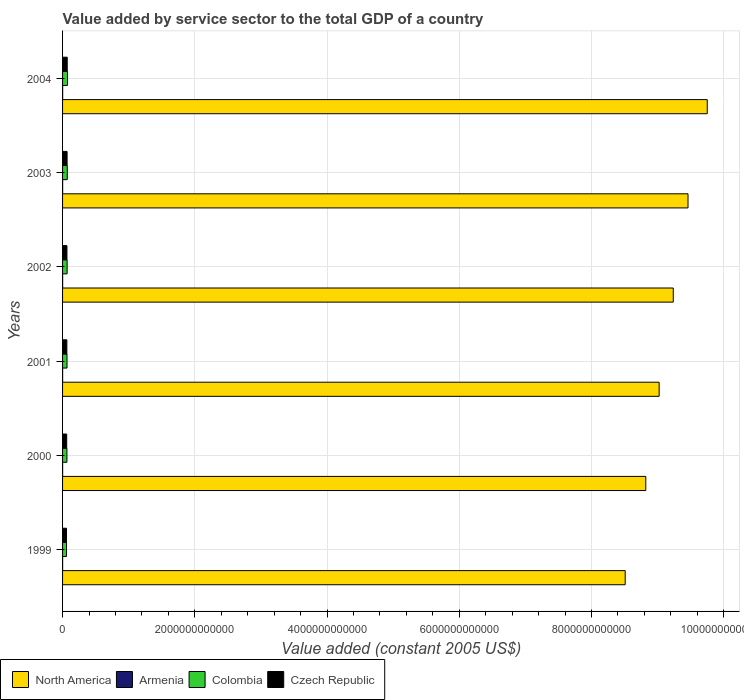In how many cases, is the number of bars for a given year not equal to the number of legend labels?
Keep it short and to the point. 0. What is the value added by service sector in Colombia in 2002?
Your answer should be very brief. 6.89e+1. Across all years, what is the maximum value added by service sector in North America?
Provide a succinct answer. 9.75e+12. Across all years, what is the minimum value added by service sector in North America?
Your response must be concise. 8.51e+12. In which year was the value added by service sector in North America maximum?
Give a very brief answer. 2004. What is the total value added by service sector in Armenia in the graph?
Offer a terse response. 6.06e+09. What is the difference between the value added by service sector in Czech Republic in 2000 and that in 2001?
Keep it short and to the point. -2.32e+09. What is the difference between the value added by service sector in Armenia in 2004 and the value added by service sector in Colombia in 2000?
Keep it short and to the point. -6.45e+1. What is the average value added by service sector in Armenia per year?
Offer a terse response. 1.01e+09. In the year 2004, what is the difference between the value added by service sector in Armenia and value added by service sector in Czech Republic?
Ensure brevity in your answer.  -6.91e+1. What is the ratio of the value added by service sector in North America in 2000 to that in 2001?
Provide a short and direct response. 0.98. Is the difference between the value added by service sector in Armenia in 2001 and 2002 greater than the difference between the value added by service sector in Czech Republic in 2001 and 2002?
Make the answer very short. Yes. What is the difference between the highest and the second highest value added by service sector in North America?
Provide a short and direct response. 2.91e+11. What is the difference between the highest and the lowest value added by service sector in Czech Republic?
Your response must be concise. 1.06e+1. Is it the case that in every year, the sum of the value added by service sector in Czech Republic and value added by service sector in North America is greater than the sum of value added by service sector in Colombia and value added by service sector in Armenia?
Give a very brief answer. Yes. What does the 1st bar from the bottom in 2004 represents?
Make the answer very short. North America. Is it the case that in every year, the sum of the value added by service sector in Colombia and value added by service sector in Armenia is greater than the value added by service sector in North America?
Provide a short and direct response. No. How many bars are there?
Offer a very short reply. 24. Are all the bars in the graph horizontal?
Make the answer very short. Yes. How many years are there in the graph?
Ensure brevity in your answer.  6. What is the difference between two consecutive major ticks on the X-axis?
Provide a short and direct response. 2.00e+12. Are the values on the major ticks of X-axis written in scientific E-notation?
Give a very brief answer. No. Where does the legend appear in the graph?
Your response must be concise. Bottom left. How many legend labels are there?
Offer a terse response. 4. How are the legend labels stacked?
Give a very brief answer. Horizontal. What is the title of the graph?
Keep it short and to the point. Value added by service sector to the total GDP of a country. Does "Bolivia" appear as one of the legend labels in the graph?
Provide a succinct answer. No. What is the label or title of the X-axis?
Provide a short and direct response. Value added (constant 2005 US$). What is the Value added (constant 2005 US$) in North America in 1999?
Ensure brevity in your answer.  8.51e+12. What is the Value added (constant 2005 US$) in Armenia in 1999?
Your response must be concise. 8.71e+08. What is the Value added (constant 2005 US$) in Colombia in 1999?
Your response must be concise. 5.97e+1. What is the Value added (constant 2005 US$) of Czech Republic in 1999?
Your response must be concise. 5.97e+1. What is the Value added (constant 2005 US$) of North America in 2000?
Make the answer very short. 8.82e+12. What is the Value added (constant 2005 US$) of Armenia in 2000?
Keep it short and to the point. 8.15e+08. What is the Value added (constant 2005 US$) in Colombia in 2000?
Offer a terse response. 6.58e+1. What is the Value added (constant 2005 US$) of Czech Republic in 2000?
Your response must be concise. 6.26e+1. What is the Value added (constant 2005 US$) in North America in 2001?
Give a very brief answer. 9.02e+12. What is the Value added (constant 2005 US$) of Armenia in 2001?
Your response must be concise. 8.94e+08. What is the Value added (constant 2005 US$) in Colombia in 2001?
Provide a short and direct response. 6.72e+1. What is the Value added (constant 2005 US$) of Czech Republic in 2001?
Give a very brief answer. 6.49e+1. What is the Value added (constant 2005 US$) in North America in 2002?
Offer a very short reply. 9.24e+12. What is the Value added (constant 2005 US$) of Armenia in 2002?
Make the answer very short. 1.02e+09. What is the Value added (constant 2005 US$) in Colombia in 2002?
Your answer should be compact. 6.89e+1. What is the Value added (constant 2005 US$) in Czech Republic in 2002?
Offer a terse response. 6.60e+1. What is the Value added (constant 2005 US$) of North America in 2003?
Offer a terse response. 9.46e+12. What is the Value added (constant 2005 US$) in Armenia in 2003?
Provide a succinct answer. 1.15e+09. What is the Value added (constant 2005 US$) of Colombia in 2003?
Ensure brevity in your answer.  7.12e+1. What is the Value added (constant 2005 US$) in Czech Republic in 2003?
Give a very brief answer. 6.84e+1. What is the Value added (constant 2005 US$) in North America in 2004?
Give a very brief answer. 9.75e+12. What is the Value added (constant 2005 US$) in Armenia in 2004?
Give a very brief answer. 1.31e+09. What is the Value added (constant 2005 US$) in Colombia in 2004?
Offer a terse response. 7.51e+1. What is the Value added (constant 2005 US$) in Czech Republic in 2004?
Offer a very short reply. 7.04e+1. Across all years, what is the maximum Value added (constant 2005 US$) in North America?
Provide a short and direct response. 9.75e+12. Across all years, what is the maximum Value added (constant 2005 US$) in Armenia?
Make the answer very short. 1.31e+09. Across all years, what is the maximum Value added (constant 2005 US$) of Colombia?
Provide a succinct answer. 7.51e+1. Across all years, what is the maximum Value added (constant 2005 US$) in Czech Republic?
Your answer should be very brief. 7.04e+1. Across all years, what is the minimum Value added (constant 2005 US$) of North America?
Offer a very short reply. 8.51e+12. Across all years, what is the minimum Value added (constant 2005 US$) in Armenia?
Your answer should be compact. 8.15e+08. Across all years, what is the minimum Value added (constant 2005 US$) in Colombia?
Make the answer very short. 5.97e+1. Across all years, what is the minimum Value added (constant 2005 US$) in Czech Republic?
Provide a succinct answer. 5.97e+1. What is the total Value added (constant 2005 US$) of North America in the graph?
Your answer should be very brief. 5.48e+13. What is the total Value added (constant 2005 US$) in Armenia in the graph?
Provide a succinct answer. 6.06e+09. What is the total Value added (constant 2005 US$) in Colombia in the graph?
Your answer should be compact. 4.08e+11. What is the total Value added (constant 2005 US$) of Czech Republic in the graph?
Ensure brevity in your answer.  3.92e+11. What is the difference between the Value added (constant 2005 US$) in North America in 1999 and that in 2000?
Ensure brevity in your answer.  -3.11e+11. What is the difference between the Value added (constant 2005 US$) of Armenia in 1999 and that in 2000?
Your answer should be very brief. 5.53e+07. What is the difference between the Value added (constant 2005 US$) of Colombia in 1999 and that in 2000?
Offer a terse response. -6.11e+09. What is the difference between the Value added (constant 2005 US$) of Czech Republic in 1999 and that in 2000?
Offer a very short reply. -2.88e+09. What is the difference between the Value added (constant 2005 US$) in North America in 1999 and that in 2001?
Make the answer very short. -5.13e+11. What is the difference between the Value added (constant 2005 US$) in Armenia in 1999 and that in 2001?
Offer a terse response. -2.38e+07. What is the difference between the Value added (constant 2005 US$) of Colombia in 1999 and that in 2001?
Make the answer very short. -7.53e+09. What is the difference between the Value added (constant 2005 US$) of Czech Republic in 1999 and that in 2001?
Provide a short and direct response. -5.19e+09. What is the difference between the Value added (constant 2005 US$) in North America in 1999 and that in 2002?
Ensure brevity in your answer.  -7.27e+11. What is the difference between the Value added (constant 2005 US$) in Armenia in 1999 and that in 2002?
Your response must be concise. -1.48e+08. What is the difference between the Value added (constant 2005 US$) of Colombia in 1999 and that in 2002?
Give a very brief answer. -9.19e+09. What is the difference between the Value added (constant 2005 US$) of Czech Republic in 1999 and that in 2002?
Offer a very short reply. -6.28e+09. What is the difference between the Value added (constant 2005 US$) of North America in 1999 and that in 2003?
Give a very brief answer. -9.50e+11. What is the difference between the Value added (constant 2005 US$) of Armenia in 1999 and that in 2003?
Keep it short and to the point. -2.79e+08. What is the difference between the Value added (constant 2005 US$) in Colombia in 1999 and that in 2003?
Ensure brevity in your answer.  -1.15e+1. What is the difference between the Value added (constant 2005 US$) in Czech Republic in 1999 and that in 2003?
Your answer should be compact. -8.66e+09. What is the difference between the Value added (constant 2005 US$) in North America in 1999 and that in 2004?
Offer a terse response. -1.24e+12. What is the difference between the Value added (constant 2005 US$) of Armenia in 1999 and that in 2004?
Make the answer very short. -4.38e+08. What is the difference between the Value added (constant 2005 US$) in Colombia in 1999 and that in 2004?
Keep it short and to the point. -1.54e+1. What is the difference between the Value added (constant 2005 US$) in Czech Republic in 1999 and that in 2004?
Offer a terse response. -1.06e+1. What is the difference between the Value added (constant 2005 US$) of North America in 2000 and that in 2001?
Make the answer very short. -2.02e+11. What is the difference between the Value added (constant 2005 US$) in Armenia in 2000 and that in 2001?
Your answer should be very brief. -7.90e+07. What is the difference between the Value added (constant 2005 US$) in Colombia in 2000 and that in 2001?
Give a very brief answer. -1.42e+09. What is the difference between the Value added (constant 2005 US$) of Czech Republic in 2000 and that in 2001?
Your response must be concise. -2.32e+09. What is the difference between the Value added (constant 2005 US$) in North America in 2000 and that in 2002?
Keep it short and to the point. -4.16e+11. What is the difference between the Value added (constant 2005 US$) of Armenia in 2000 and that in 2002?
Offer a terse response. -2.03e+08. What is the difference between the Value added (constant 2005 US$) of Colombia in 2000 and that in 2002?
Your response must be concise. -3.07e+09. What is the difference between the Value added (constant 2005 US$) in Czech Republic in 2000 and that in 2002?
Your response must be concise. -3.40e+09. What is the difference between the Value added (constant 2005 US$) of North America in 2000 and that in 2003?
Your response must be concise. -6.39e+11. What is the difference between the Value added (constant 2005 US$) of Armenia in 2000 and that in 2003?
Provide a succinct answer. -3.34e+08. What is the difference between the Value added (constant 2005 US$) in Colombia in 2000 and that in 2003?
Ensure brevity in your answer.  -5.41e+09. What is the difference between the Value added (constant 2005 US$) in Czech Republic in 2000 and that in 2003?
Your response must be concise. -5.79e+09. What is the difference between the Value added (constant 2005 US$) of North America in 2000 and that in 2004?
Give a very brief answer. -9.30e+11. What is the difference between the Value added (constant 2005 US$) of Armenia in 2000 and that in 2004?
Make the answer very short. -4.93e+08. What is the difference between the Value added (constant 2005 US$) in Colombia in 2000 and that in 2004?
Offer a terse response. -9.33e+09. What is the difference between the Value added (constant 2005 US$) in Czech Republic in 2000 and that in 2004?
Ensure brevity in your answer.  -7.77e+09. What is the difference between the Value added (constant 2005 US$) in North America in 2001 and that in 2002?
Make the answer very short. -2.14e+11. What is the difference between the Value added (constant 2005 US$) in Armenia in 2001 and that in 2002?
Your answer should be very brief. -1.24e+08. What is the difference between the Value added (constant 2005 US$) in Colombia in 2001 and that in 2002?
Your answer should be very brief. -1.65e+09. What is the difference between the Value added (constant 2005 US$) of Czech Republic in 2001 and that in 2002?
Your response must be concise. -1.08e+09. What is the difference between the Value added (constant 2005 US$) of North America in 2001 and that in 2003?
Give a very brief answer. -4.37e+11. What is the difference between the Value added (constant 2005 US$) in Armenia in 2001 and that in 2003?
Make the answer very short. -2.55e+08. What is the difference between the Value added (constant 2005 US$) of Colombia in 2001 and that in 2003?
Keep it short and to the point. -3.99e+09. What is the difference between the Value added (constant 2005 US$) of Czech Republic in 2001 and that in 2003?
Make the answer very short. -3.47e+09. What is the difference between the Value added (constant 2005 US$) of North America in 2001 and that in 2004?
Offer a very short reply. -7.28e+11. What is the difference between the Value added (constant 2005 US$) of Armenia in 2001 and that in 2004?
Make the answer very short. -4.14e+08. What is the difference between the Value added (constant 2005 US$) in Colombia in 2001 and that in 2004?
Provide a succinct answer. -7.91e+09. What is the difference between the Value added (constant 2005 US$) of Czech Republic in 2001 and that in 2004?
Your response must be concise. -5.45e+09. What is the difference between the Value added (constant 2005 US$) of North America in 2002 and that in 2003?
Provide a succinct answer. -2.23e+11. What is the difference between the Value added (constant 2005 US$) of Armenia in 2002 and that in 2003?
Your response must be concise. -1.31e+08. What is the difference between the Value added (constant 2005 US$) in Colombia in 2002 and that in 2003?
Provide a short and direct response. -2.34e+09. What is the difference between the Value added (constant 2005 US$) of Czech Republic in 2002 and that in 2003?
Your answer should be very brief. -2.39e+09. What is the difference between the Value added (constant 2005 US$) of North America in 2002 and that in 2004?
Ensure brevity in your answer.  -5.14e+11. What is the difference between the Value added (constant 2005 US$) of Armenia in 2002 and that in 2004?
Offer a very short reply. -2.90e+08. What is the difference between the Value added (constant 2005 US$) of Colombia in 2002 and that in 2004?
Give a very brief answer. -6.26e+09. What is the difference between the Value added (constant 2005 US$) in Czech Republic in 2002 and that in 2004?
Your answer should be compact. -4.37e+09. What is the difference between the Value added (constant 2005 US$) in North America in 2003 and that in 2004?
Give a very brief answer. -2.91e+11. What is the difference between the Value added (constant 2005 US$) in Armenia in 2003 and that in 2004?
Give a very brief answer. -1.59e+08. What is the difference between the Value added (constant 2005 US$) in Colombia in 2003 and that in 2004?
Your answer should be very brief. -3.92e+09. What is the difference between the Value added (constant 2005 US$) in Czech Republic in 2003 and that in 2004?
Offer a terse response. -1.98e+09. What is the difference between the Value added (constant 2005 US$) in North America in 1999 and the Value added (constant 2005 US$) in Armenia in 2000?
Give a very brief answer. 8.51e+12. What is the difference between the Value added (constant 2005 US$) of North America in 1999 and the Value added (constant 2005 US$) of Colombia in 2000?
Ensure brevity in your answer.  8.44e+12. What is the difference between the Value added (constant 2005 US$) in North America in 1999 and the Value added (constant 2005 US$) in Czech Republic in 2000?
Give a very brief answer. 8.45e+12. What is the difference between the Value added (constant 2005 US$) in Armenia in 1999 and the Value added (constant 2005 US$) in Colombia in 2000?
Provide a short and direct response. -6.49e+1. What is the difference between the Value added (constant 2005 US$) of Armenia in 1999 and the Value added (constant 2005 US$) of Czech Republic in 2000?
Make the answer very short. -6.17e+1. What is the difference between the Value added (constant 2005 US$) of Colombia in 1999 and the Value added (constant 2005 US$) of Czech Republic in 2000?
Your answer should be very brief. -2.93e+09. What is the difference between the Value added (constant 2005 US$) in North America in 1999 and the Value added (constant 2005 US$) in Armenia in 2001?
Make the answer very short. 8.51e+12. What is the difference between the Value added (constant 2005 US$) of North America in 1999 and the Value added (constant 2005 US$) of Colombia in 2001?
Give a very brief answer. 8.44e+12. What is the difference between the Value added (constant 2005 US$) in North America in 1999 and the Value added (constant 2005 US$) in Czech Republic in 2001?
Your answer should be compact. 8.45e+12. What is the difference between the Value added (constant 2005 US$) in Armenia in 1999 and the Value added (constant 2005 US$) in Colombia in 2001?
Provide a short and direct response. -6.63e+1. What is the difference between the Value added (constant 2005 US$) in Armenia in 1999 and the Value added (constant 2005 US$) in Czech Republic in 2001?
Provide a short and direct response. -6.41e+1. What is the difference between the Value added (constant 2005 US$) of Colombia in 1999 and the Value added (constant 2005 US$) of Czech Republic in 2001?
Your response must be concise. -5.25e+09. What is the difference between the Value added (constant 2005 US$) in North America in 1999 and the Value added (constant 2005 US$) in Armenia in 2002?
Provide a short and direct response. 8.51e+12. What is the difference between the Value added (constant 2005 US$) in North America in 1999 and the Value added (constant 2005 US$) in Colombia in 2002?
Ensure brevity in your answer.  8.44e+12. What is the difference between the Value added (constant 2005 US$) in North America in 1999 and the Value added (constant 2005 US$) in Czech Republic in 2002?
Your response must be concise. 8.44e+12. What is the difference between the Value added (constant 2005 US$) in Armenia in 1999 and the Value added (constant 2005 US$) in Colombia in 2002?
Your answer should be very brief. -6.80e+1. What is the difference between the Value added (constant 2005 US$) in Armenia in 1999 and the Value added (constant 2005 US$) in Czech Republic in 2002?
Provide a short and direct response. -6.51e+1. What is the difference between the Value added (constant 2005 US$) in Colombia in 1999 and the Value added (constant 2005 US$) in Czech Republic in 2002?
Your response must be concise. -6.33e+09. What is the difference between the Value added (constant 2005 US$) in North America in 1999 and the Value added (constant 2005 US$) in Armenia in 2003?
Your answer should be very brief. 8.51e+12. What is the difference between the Value added (constant 2005 US$) in North America in 1999 and the Value added (constant 2005 US$) in Colombia in 2003?
Your response must be concise. 8.44e+12. What is the difference between the Value added (constant 2005 US$) in North America in 1999 and the Value added (constant 2005 US$) in Czech Republic in 2003?
Ensure brevity in your answer.  8.44e+12. What is the difference between the Value added (constant 2005 US$) of Armenia in 1999 and the Value added (constant 2005 US$) of Colombia in 2003?
Make the answer very short. -7.03e+1. What is the difference between the Value added (constant 2005 US$) of Armenia in 1999 and the Value added (constant 2005 US$) of Czech Republic in 2003?
Your answer should be very brief. -6.75e+1. What is the difference between the Value added (constant 2005 US$) of Colombia in 1999 and the Value added (constant 2005 US$) of Czech Republic in 2003?
Give a very brief answer. -8.72e+09. What is the difference between the Value added (constant 2005 US$) of North America in 1999 and the Value added (constant 2005 US$) of Armenia in 2004?
Provide a short and direct response. 8.51e+12. What is the difference between the Value added (constant 2005 US$) in North America in 1999 and the Value added (constant 2005 US$) in Colombia in 2004?
Your response must be concise. 8.44e+12. What is the difference between the Value added (constant 2005 US$) in North America in 1999 and the Value added (constant 2005 US$) in Czech Republic in 2004?
Your answer should be very brief. 8.44e+12. What is the difference between the Value added (constant 2005 US$) of Armenia in 1999 and the Value added (constant 2005 US$) of Colombia in 2004?
Your answer should be very brief. -7.43e+1. What is the difference between the Value added (constant 2005 US$) of Armenia in 1999 and the Value added (constant 2005 US$) of Czech Republic in 2004?
Provide a succinct answer. -6.95e+1. What is the difference between the Value added (constant 2005 US$) in Colombia in 1999 and the Value added (constant 2005 US$) in Czech Republic in 2004?
Provide a short and direct response. -1.07e+1. What is the difference between the Value added (constant 2005 US$) in North America in 2000 and the Value added (constant 2005 US$) in Armenia in 2001?
Offer a very short reply. 8.82e+12. What is the difference between the Value added (constant 2005 US$) in North America in 2000 and the Value added (constant 2005 US$) in Colombia in 2001?
Make the answer very short. 8.75e+12. What is the difference between the Value added (constant 2005 US$) in North America in 2000 and the Value added (constant 2005 US$) in Czech Republic in 2001?
Provide a succinct answer. 8.76e+12. What is the difference between the Value added (constant 2005 US$) in Armenia in 2000 and the Value added (constant 2005 US$) in Colombia in 2001?
Give a very brief answer. -6.64e+1. What is the difference between the Value added (constant 2005 US$) of Armenia in 2000 and the Value added (constant 2005 US$) of Czech Republic in 2001?
Your answer should be compact. -6.41e+1. What is the difference between the Value added (constant 2005 US$) in Colombia in 2000 and the Value added (constant 2005 US$) in Czech Republic in 2001?
Give a very brief answer. 8.67e+08. What is the difference between the Value added (constant 2005 US$) of North America in 2000 and the Value added (constant 2005 US$) of Armenia in 2002?
Offer a terse response. 8.82e+12. What is the difference between the Value added (constant 2005 US$) in North America in 2000 and the Value added (constant 2005 US$) in Colombia in 2002?
Give a very brief answer. 8.75e+12. What is the difference between the Value added (constant 2005 US$) of North America in 2000 and the Value added (constant 2005 US$) of Czech Republic in 2002?
Your answer should be very brief. 8.76e+12. What is the difference between the Value added (constant 2005 US$) of Armenia in 2000 and the Value added (constant 2005 US$) of Colombia in 2002?
Provide a succinct answer. -6.81e+1. What is the difference between the Value added (constant 2005 US$) in Armenia in 2000 and the Value added (constant 2005 US$) in Czech Republic in 2002?
Provide a short and direct response. -6.52e+1. What is the difference between the Value added (constant 2005 US$) of Colombia in 2000 and the Value added (constant 2005 US$) of Czech Republic in 2002?
Give a very brief answer. -2.14e+08. What is the difference between the Value added (constant 2005 US$) in North America in 2000 and the Value added (constant 2005 US$) in Armenia in 2003?
Your answer should be compact. 8.82e+12. What is the difference between the Value added (constant 2005 US$) in North America in 2000 and the Value added (constant 2005 US$) in Colombia in 2003?
Give a very brief answer. 8.75e+12. What is the difference between the Value added (constant 2005 US$) in North America in 2000 and the Value added (constant 2005 US$) in Czech Republic in 2003?
Your answer should be very brief. 8.75e+12. What is the difference between the Value added (constant 2005 US$) of Armenia in 2000 and the Value added (constant 2005 US$) of Colombia in 2003?
Ensure brevity in your answer.  -7.04e+1. What is the difference between the Value added (constant 2005 US$) of Armenia in 2000 and the Value added (constant 2005 US$) of Czech Republic in 2003?
Offer a very short reply. -6.76e+1. What is the difference between the Value added (constant 2005 US$) of Colombia in 2000 and the Value added (constant 2005 US$) of Czech Republic in 2003?
Offer a very short reply. -2.60e+09. What is the difference between the Value added (constant 2005 US$) in North America in 2000 and the Value added (constant 2005 US$) in Armenia in 2004?
Offer a terse response. 8.82e+12. What is the difference between the Value added (constant 2005 US$) in North America in 2000 and the Value added (constant 2005 US$) in Colombia in 2004?
Provide a succinct answer. 8.75e+12. What is the difference between the Value added (constant 2005 US$) of North America in 2000 and the Value added (constant 2005 US$) of Czech Republic in 2004?
Ensure brevity in your answer.  8.75e+12. What is the difference between the Value added (constant 2005 US$) in Armenia in 2000 and the Value added (constant 2005 US$) in Colombia in 2004?
Ensure brevity in your answer.  -7.43e+1. What is the difference between the Value added (constant 2005 US$) in Armenia in 2000 and the Value added (constant 2005 US$) in Czech Republic in 2004?
Provide a short and direct response. -6.96e+1. What is the difference between the Value added (constant 2005 US$) in Colombia in 2000 and the Value added (constant 2005 US$) in Czech Republic in 2004?
Make the answer very short. -4.58e+09. What is the difference between the Value added (constant 2005 US$) in North America in 2001 and the Value added (constant 2005 US$) in Armenia in 2002?
Provide a short and direct response. 9.02e+12. What is the difference between the Value added (constant 2005 US$) in North America in 2001 and the Value added (constant 2005 US$) in Colombia in 2002?
Your response must be concise. 8.95e+12. What is the difference between the Value added (constant 2005 US$) of North America in 2001 and the Value added (constant 2005 US$) of Czech Republic in 2002?
Make the answer very short. 8.96e+12. What is the difference between the Value added (constant 2005 US$) of Armenia in 2001 and the Value added (constant 2005 US$) of Colombia in 2002?
Your answer should be compact. -6.80e+1. What is the difference between the Value added (constant 2005 US$) in Armenia in 2001 and the Value added (constant 2005 US$) in Czech Republic in 2002?
Your answer should be compact. -6.51e+1. What is the difference between the Value added (constant 2005 US$) of Colombia in 2001 and the Value added (constant 2005 US$) of Czech Republic in 2002?
Offer a very short reply. 1.20e+09. What is the difference between the Value added (constant 2005 US$) of North America in 2001 and the Value added (constant 2005 US$) of Armenia in 2003?
Your response must be concise. 9.02e+12. What is the difference between the Value added (constant 2005 US$) in North America in 2001 and the Value added (constant 2005 US$) in Colombia in 2003?
Your answer should be compact. 8.95e+12. What is the difference between the Value added (constant 2005 US$) in North America in 2001 and the Value added (constant 2005 US$) in Czech Republic in 2003?
Give a very brief answer. 8.96e+12. What is the difference between the Value added (constant 2005 US$) of Armenia in 2001 and the Value added (constant 2005 US$) of Colombia in 2003?
Your answer should be compact. -7.03e+1. What is the difference between the Value added (constant 2005 US$) in Armenia in 2001 and the Value added (constant 2005 US$) in Czech Republic in 2003?
Your response must be concise. -6.75e+1. What is the difference between the Value added (constant 2005 US$) in Colombia in 2001 and the Value added (constant 2005 US$) in Czech Republic in 2003?
Ensure brevity in your answer.  -1.18e+09. What is the difference between the Value added (constant 2005 US$) in North America in 2001 and the Value added (constant 2005 US$) in Armenia in 2004?
Provide a short and direct response. 9.02e+12. What is the difference between the Value added (constant 2005 US$) in North America in 2001 and the Value added (constant 2005 US$) in Colombia in 2004?
Your answer should be very brief. 8.95e+12. What is the difference between the Value added (constant 2005 US$) in North America in 2001 and the Value added (constant 2005 US$) in Czech Republic in 2004?
Your response must be concise. 8.95e+12. What is the difference between the Value added (constant 2005 US$) in Armenia in 2001 and the Value added (constant 2005 US$) in Colombia in 2004?
Your answer should be compact. -7.42e+1. What is the difference between the Value added (constant 2005 US$) of Armenia in 2001 and the Value added (constant 2005 US$) of Czech Republic in 2004?
Provide a succinct answer. -6.95e+1. What is the difference between the Value added (constant 2005 US$) in Colombia in 2001 and the Value added (constant 2005 US$) in Czech Republic in 2004?
Your answer should be very brief. -3.16e+09. What is the difference between the Value added (constant 2005 US$) of North America in 2002 and the Value added (constant 2005 US$) of Armenia in 2003?
Offer a terse response. 9.24e+12. What is the difference between the Value added (constant 2005 US$) in North America in 2002 and the Value added (constant 2005 US$) in Colombia in 2003?
Keep it short and to the point. 9.17e+12. What is the difference between the Value added (constant 2005 US$) in North America in 2002 and the Value added (constant 2005 US$) in Czech Republic in 2003?
Offer a very short reply. 9.17e+12. What is the difference between the Value added (constant 2005 US$) in Armenia in 2002 and the Value added (constant 2005 US$) in Colombia in 2003?
Ensure brevity in your answer.  -7.02e+1. What is the difference between the Value added (constant 2005 US$) in Armenia in 2002 and the Value added (constant 2005 US$) in Czech Republic in 2003?
Keep it short and to the point. -6.74e+1. What is the difference between the Value added (constant 2005 US$) in Colombia in 2002 and the Value added (constant 2005 US$) in Czech Republic in 2003?
Offer a very short reply. 4.68e+08. What is the difference between the Value added (constant 2005 US$) in North America in 2002 and the Value added (constant 2005 US$) in Armenia in 2004?
Keep it short and to the point. 9.24e+12. What is the difference between the Value added (constant 2005 US$) of North America in 2002 and the Value added (constant 2005 US$) of Colombia in 2004?
Ensure brevity in your answer.  9.16e+12. What is the difference between the Value added (constant 2005 US$) in North America in 2002 and the Value added (constant 2005 US$) in Czech Republic in 2004?
Provide a short and direct response. 9.17e+12. What is the difference between the Value added (constant 2005 US$) of Armenia in 2002 and the Value added (constant 2005 US$) of Colombia in 2004?
Ensure brevity in your answer.  -7.41e+1. What is the difference between the Value added (constant 2005 US$) of Armenia in 2002 and the Value added (constant 2005 US$) of Czech Republic in 2004?
Give a very brief answer. -6.94e+1. What is the difference between the Value added (constant 2005 US$) of Colombia in 2002 and the Value added (constant 2005 US$) of Czech Republic in 2004?
Keep it short and to the point. -1.51e+09. What is the difference between the Value added (constant 2005 US$) in North America in 2003 and the Value added (constant 2005 US$) in Armenia in 2004?
Your response must be concise. 9.46e+12. What is the difference between the Value added (constant 2005 US$) in North America in 2003 and the Value added (constant 2005 US$) in Colombia in 2004?
Offer a terse response. 9.39e+12. What is the difference between the Value added (constant 2005 US$) of North America in 2003 and the Value added (constant 2005 US$) of Czech Republic in 2004?
Make the answer very short. 9.39e+12. What is the difference between the Value added (constant 2005 US$) in Armenia in 2003 and the Value added (constant 2005 US$) in Colombia in 2004?
Give a very brief answer. -7.40e+1. What is the difference between the Value added (constant 2005 US$) of Armenia in 2003 and the Value added (constant 2005 US$) of Czech Republic in 2004?
Your answer should be very brief. -6.92e+1. What is the difference between the Value added (constant 2005 US$) of Colombia in 2003 and the Value added (constant 2005 US$) of Czech Republic in 2004?
Make the answer very short. 8.26e+08. What is the average Value added (constant 2005 US$) in North America per year?
Ensure brevity in your answer.  9.13e+12. What is the average Value added (constant 2005 US$) in Armenia per year?
Provide a succinct answer. 1.01e+09. What is the average Value added (constant 2005 US$) of Colombia per year?
Keep it short and to the point. 6.80e+1. What is the average Value added (constant 2005 US$) of Czech Republic per year?
Your response must be concise. 6.53e+1. In the year 1999, what is the difference between the Value added (constant 2005 US$) of North America and Value added (constant 2005 US$) of Armenia?
Your response must be concise. 8.51e+12. In the year 1999, what is the difference between the Value added (constant 2005 US$) of North America and Value added (constant 2005 US$) of Colombia?
Make the answer very short. 8.45e+12. In the year 1999, what is the difference between the Value added (constant 2005 US$) of North America and Value added (constant 2005 US$) of Czech Republic?
Offer a terse response. 8.45e+12. In the year 1999, what is the difference between the Value added (constant 2005 US$) of Armenia and Value added (constant 2005 US$) of Colombia?
Provide a short and direct response. -5.88e+1. In the year 1999, what is the difference between the Value added (constant 2005 US$) in Armenia and Value added (constant 2005 US$) in Czech Republic?
Your answer should be very brief. -5.89e+1. In the year 1999, what is the difference between the Value added (constant 2005 US$) in Colombia and Value added (constant 2005 US$) in Czech Republic?
Make the answer very short. -5.26e+07. In the year 2000, what is the difference between the Value added (constant 2005 US$) of North America and Value added (constant 2005 US$) of Armenia?
Offer a terse response. 8.82e+12. In the year 2000, what is the difference between the Value added (constant 2005 US$) of North America and Value added (constant 2005 US$) of Colombia?
Give a very brief answer. 8.76e+12. In the year 2000, what is the difference between the Value added (constant 2005 US$) of North America and Value added (constant 2005 US$) of Czech Republic?
Offer a very short reply. 8.76e+12. In the year 2000, what is the difference between the Value added (constant 2005 US$) of Armenia and Value added (constant 2005 US$) of Colombia?
Offer a very short reply. -6.50e+1. In the year 2000, what is the difference between the Value added (constant 2005 US$) of Armenia and Value added (constant 2005 US$) of Czech Republic?
Provide a short and direct response. -6.18e+1. In the year 2000, what is the difference between the Value added (constant 2005 US$) in Colombia and Value added (constant 2005 US$) in Czech Republic?
Your answer should be compact. 3.18e+09. In the year 2001, what is the difference between the Value added (constant 2005 US$) in North America and Value added (constant 2005 US$) in Armenia?
Your response must be concise. 9.02e+12. In the year 2001, what is the difference between the Value added (constant 2005 US$) of North America and Value added (constant 2005 US$) of Colombia?
Make the answer very short. 8.96e+12. In the year 2001, what is the difference between the Value added (constant 2005 US$) in North America and Value added (constant 2005 US$) in Czech Republic?
Provide a succinct answer. 8.96e+12. In the year 2001, what is the difference between the Value added (constant 2005 US$) in Armenia and Value added (constant 2005 US$) in Colombia?
Make the answer very short. -6.63e+1. In the year 2001, what is the difference between the Value added (constant 2005 US$) in Armenia and Value added (constant 2005 US$) in Czech Republic?
Your answer should be very brief. -6.40e+1. In the year 2001, what is the difference between the Value added (constant 2005 US$) of Colombia and Value added (constant 2005 US$) of Czech Republic?
Give a very brief answer. 2.29e+09. In the year 2002, what is the difference between the Value added (constant 2005 US$) of North America and Value added (constant 2005 US$) of Armenia?
Your answer should be compact. 9.24e+12. In the year 2002, what is the difference between the Value added (constant 2005 US$) in North America and Value added (constant 2005 US$) in Colombia?
Offer a terse response. 9.17e+12. In the year 2002, what is the difference between the Value added (constant 2005 US$) of North America and Value added (constant 2005 US$) of Czech Republic?
Your answer should be very brief. 9.17e+12. In the year 2002, what is the difference between the Value added (constant 2005 US$) of Armenia and Value added (constant 2005 US$) of Colombia?
Make the answer very short. -6.79e+1. In the year 2002, what is the difference between the Value added (constant 2005 US$) of Armenia and Value added (constant 2005 US$) of Czech Republic?
Ensure brevity in your answer.  -6.50e+1. In the year 2002, what is the difference between the Value added (constant 2005 US$) of Colombia and Value added (constant 2005 US$) of Czech Republic?
Make the answer very short. 2.86e+09. In the year 2003, what is the difference between the Value added (constant 2005 US$) in North America and Value added (constant 2005 US$) in Armenia?
Your answer should be very brief. 9.46e+12. In the year 2003, what is the difference between the Value added (constant 2005 US$) in North America and Value added (constant 2005 US$) in Colombia?
Make the answer very short. 9.39e+12. In the year 2003, what is the difference between the Value added (constant 2005 US$) in North America and Value added (constant 2005 US$) in Czech Republic?
Ensure brevity in your answer.  9.39e+12. In the year 2003, what is the difference between the Value added (constant 2005 US$) of Armenia and Value added (constant 2005 US$) of Colombia?
Keep it short and to the point. -7.01e+1. In the year 2003, what is the difference between the Value added (constant 2005 US$) in Armenia and Value added (constant 2005 US$) in Czech Republic?
Provide a succinct answer. -6.73e+1. In the year 2003, what is the difference between the Value added (constant 2005 US$) in Colombia and Value added (constant 2005 US$) in Czech Republic?
Offer a terse response. 2.80e+09. In the year 2004, what is the difference between the Value added (constant 2005 US$) of North America and Value added (constant 2005 US$) of Armenia?
Make the answer very short. 9.75e+12. In the year 2004, what is the difference between the Value added (constant 2005 US$) of North America and Value added (constant 2005 US$) of Colombia?
Your answer should be very brief. 9.68e+12. In the year 2004, what is the difference between the Value added (constant 2005 US$) of North America and Value added (constant 2005 US$) of Czech Republic?
Provide a succinct answer. 9.68e+12. In the year 2004, what is the difference between the Value added (constant 2005 US$) of Armenia and Value added (constant 2005 US$) of Colombia?
Make the answer very short. -7.38e+1. In the year 2004, what is the difference between the Value added (constant 2005 US$) of Armenia and Value added (constant 2005 US$) of Czech Republic?
Make the answer very short. -6.91e+1. In the year 2004, what is the difference between the Value added (constant 2005 US$) in Colombia and Value added (constant 2005 US$) in Czech Republic?
Offer a terse response. 4.75e+09. What is the ratio of the Value added (constant 2005 US$) of North America in 1999 to that in 2000?
Provide a short and direct response. 0.96. What is the ratio of the Value added (constant 2005 US$) of Armenia in 1999 to that in 2000?
Offer a very short reply. 1.07. What is the ratio of the Value added (constant 2005 US$) of Colombia in 1999 to that in 2000?
Keep it short and to the point. 0.91. What is the ratio of the Value added (constant 2005 US$) in Czech Republic in 1999 to that in 2000?
Your answer should be very brief. 0.95. What is the ratio of the Value added (constant 2005 US$) of North America in 1999 to that in 2001?
Your answer should be very brief. 0.94. What is the ratio of the Value added (constant 2005 US$) in Armenia in 1999 to that in 2001?
Make the answer very short. 0.97. What is the ratio of the Value added (constant 2005 US$) of Colombia in 1999 to that in 2001?
Your response must be concise. 0.89. What is the ratio of the Value added (constant 2005 US$) of North America in 1999 to that in 2002?
Make the answer very short. 0.92. What is the ratio of the Value added (constant 2005 US$) of Armenia in 1999 to that in 2002?
Give a very brief answer. 0.86. What is the ratio of the Value added (constant 2005 US$) of Colombia in 1999 to that in 2002?
Your response must be concise. 0.87. What is the ratio of the Value added (constant 2005 US$) in Czech Republic in 1999 to that in 2002?
Provide a succinct answer. 0.9. What is the ratio of the Value added (constant 2005 US$) in North America in 1999 to that in 2003?
Ensure brevity in your answer.  0.9. What is the ratio of the Value added (constant 2005 US$) of Armenia in 1999 to that in 2003?
Your answer should be very brief. 0.76. What is the ratio of the Value added (constant 2005 US$) in Colombia in 1999 to that in 2003?
Your answer should be compact. 0.84. What is the ratio of the Value added (constant 2005 US$) in Czech Republic in 1999 to that in 2003?
Offer a terse response. 0.87. What is the ratio of the Value added (constant 2005 US$) in North America in 1999 to that in 2004?
Ensure brevity in your answer.  0.87. What is the ratio of the Value added (constant 2005 US$) of Armenia in 1999 to that in 2004?
Your answer should be compact. 0.67. What is the ratio of the Value added (constant 2005 US$) in Colombia in 1999 to that in 2004?
Ensure brevity in your answer.  0.79. What is the ratio of the Value added (constant 2005 US$) in Czech Republic in 1999 to that in 2004?
Give a very brief answer. 0.85. What is the ratio of the Value added (constant 2005 US$) of North America in 2000 to that in 2001?
Your response must be concise. 0.98. What is the ratio of the Value added (constant 2005 US$) in Armenia in 2000 to that in 2001?
Offer a very short reply. 0.91. What is the ratio of the Value added (constant 2005 US$) in Colombia in 2000 to that in 2001?
Provide a short and direct response. 0.98. What is the ratio of the Value added (constant 2005 US$) in North America in 2000 to that in 2002?
Your answer should be very brief. 0.95. What is the ratio of the Value added (constant 2005 US$) of Armenia in 2000 to that in 2002?
Keep it short and to the point. 0.8. What is the ratio of the Value added (constant 2005 US$) of Colombia in 2000 to that in 2002?
Keep it short and to the point. 0.96. What is the ratio of the Value added (constant 2005 US$) of Czech Republic in 2000 to that in 2002?
Provide a succinct answer. 0.95. What is the ratio of the Value added (constant 2005 US$) in North America in 2000 to that in 2003?
Your answer should be compact. 0.93. What is the ratio of the Value added (constant 2005 US$) in Armenia in 2000 to that in 2003?
Offer a very short reply. 0.71. What is the ratio of the Value added (constant 2005 US$) of Colombia in 2000 to that in 2003?
Ensure brevity in your answer.  0.92. What is the ratio of the Value added (constant 2005 US$) in Czech Republic in 2000 to that in 2003?
Provide a short and direct response. 0.92. What is the ratio of the Value added (constant 2005 US$) of North America in 2000 to that in 2004?
Give a very brief answer. 0.9. What is the ratio of the Value added (constant 2005 US$) in Armenia in 2000 to that in 2004?
Your answer should be compact. 0.62. What is the ratio of the Value added (constant 2005 US$) of Colombia in 2000 to that in 2004?
Your response must be concise. 0.88. What is the ratio of the Value added (constant 2005 US$) of Czech Republic in 2000 to that in 2004?
Offer a terse response. 0.89. What is the ratio of the Value added (constant 2005 US$) in North America in 2001 to that in 2002?
Provide a succinct answer. 0.98. What is the ratio of the Value added (constant 2005 US$) of Armenia in 2001 to that in 2002?
Offer a terse response. 0.88. What is the ratio of the Value added (constant 2005 US$) of Colombia in 2001 to that in 2002?
Your response must be concise. 0.98. What is the ratio of the Value added (constant 2005 US$) of Czech Republic in 2001 to that in 2002?
Make the answer very short. 0.98. What is the ratio of the Value added (constant 2005 US$) in North America in 2001 to that in 2003?
Provide a succinct answer. 0.95. What is the ratio of the Value added (constant 2005 US$) of Armenia in 2001 to that in 2003?
Keep it short and to the point. 0.78. What is the ratio of the Value added (constant 2005 US$) of Colombia in 2001 to that in 2003?
Your answer should be very brief. 0.94. What is the ratio of the Value added (constant 2005 US$) of Czech Republic in 2001 to that in 2003?
Give a very brief answer. 0.95. What is the ratio of the Value added (constant 2005 US$) in North America in 2001 to that in 2004?
Keep it short and to the point. 0.93. What is the ratio of the Value added (constant 2005 US$) in Armenia in 2001 to that in 2004?
Provide a succinct answer. 0.68. What is the ratio of the Value added (constant 2005 US$) in Colombia in 2001 to that in 2004?
Your answer should be compact. 0.89. What is the ratio of the Value added (constant 2005 US$) of Czech Republic in 2001 to that in 2004?
Keep it short and to the point. 0.92. What is the ratio of the Value added (constant 2005 US$) of North America in 2002 to that in 2003?
Ensure brevity in your answer.  0.98. What is the ratio of the Value added (constant 2005 US$) in Armenia in 2002 to that in 2003?
Ensure brevity in your answer.  0.89. What is the ratio of the Value added (constant 2005 US$) of Colombia in 2002 to that in 2003?
Give a very brief answer. 0.97. What is the ratio of the Value added (constant 2005 US$) in Czech Republic in 2002 to that in 2003?
Provide a short and direct response. 0.97. What is the ratio of the Value added (constant 2005 US$) in North America in 2002 to that in 2004?
Provide a succinct answer. 0.95. What is the ratio of the Value added (constant 2005 US$) in Armenia in 2002 to that in 2004?
Your answer should be very brief. 0.78. What is the ratio of the Value added (constant 2005 US$) in Colombia in 2002 to that in 2004?
Give a very brief answer. 0.92. What is the ratio of the Value added (constant 2005 US$) of Czech Republic in 2002 to that in 2004?
Offer a terse response. 0.94. What is the ratio of the Value added (constant 2005 US$) of North America in 2003 to that in 2004?
Give a very brief answer. 0.97. What is the ratio of the Value added (constant 2005 US$) in Armenia in 2003 to that in 2004?
Ensure brevity in your answer.  0.88. What is the ratio of the Value added (constant 2005 US$) of Colombia in 2003 to that in 2004?
Keep it short and to the point. 0.95. What is the ratio of the Value added (constant 2005 US$) in Czech Republic in 2003 to that in 2004?
Your answer should be very brief. 0.97. What is the difference between the highest and the second highest Value added (constant 2005 US$) in North America?
Provide a succinct answer. 2.91e+11. What is the difference between the highest and the second highest Value added (constant 2005 US$) of Armenia?
Your answer should be very brief. 1.59e+08. What is the difference between the highest and the second highest Value added (constant 2005 US$) in Colombia?
Provide a succinct answer. 3.92e+09. What is the difference between the highest and the second highest Value added (constant 2005 US$) of Czech Republic?
Keep it short and to the point. 1.98e+09. What is the difference between the highest and the lowest Value added (constant 2005 US$) in North America?
Keep it short and to the point. 1.24e+12. What is the difference between the highest and the lowest Value added (constant 2005 US$) of Armenia?
Your answer should be very brief. 4.93e+08. What is the difference between the highest and the lowest Value added (constant 2005 US$) in Colombia?
Provide a succinct answer. 1.54e+1. What is the difference between the highest and the lowest Value added (constant 2005 US$) in Czech Republic?
Your answer should be compact. 1.06e+1. 